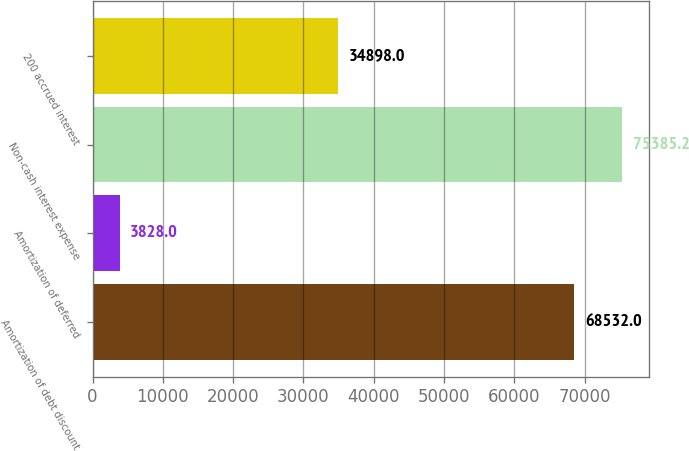Convert chart. <chart><loc_0><loc_0><loc_500><loc_500><bar_chart><fcel>Amortization of debt discount<fcel>Amortization of deferred<fcel>Non-cash interest expense<fcel>200 accrued interest<nl><fcel>68532<fcel>3828<fcel>75385.2<fcel>34898<nl></chart> 